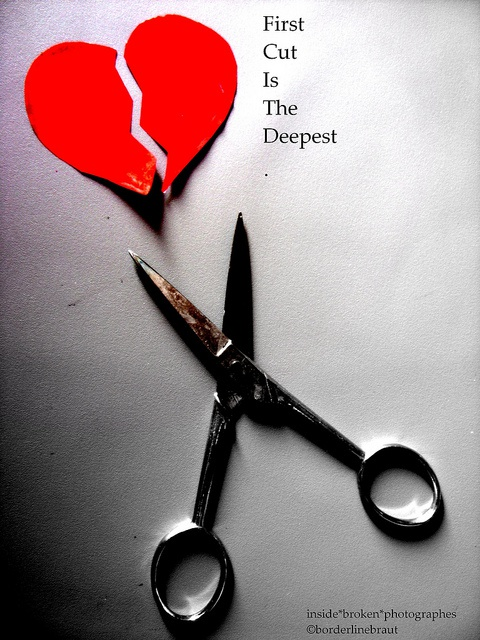Describe the objects in this image and their specific colors. I can see scissors in gray, black, darkgray, and white tones in this image. 